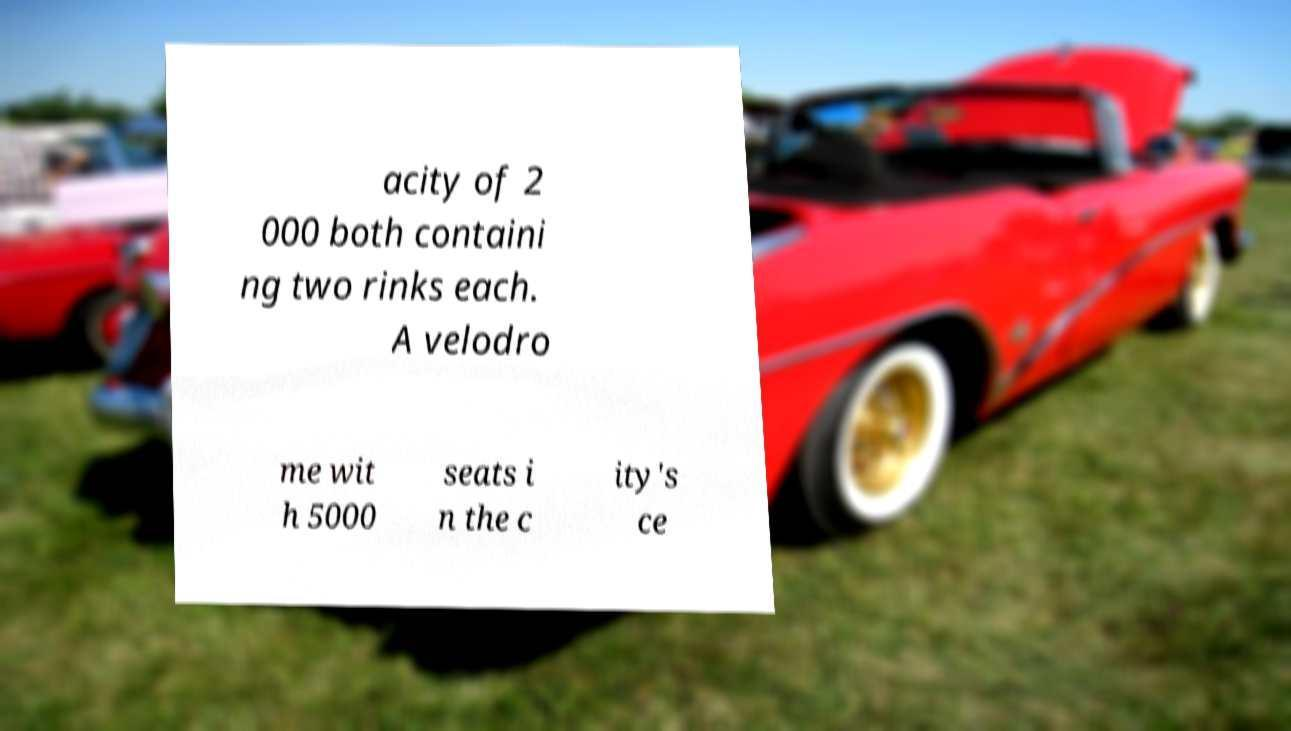What messages or text are displayed in this image? I need them in a readable, typed format. acity of 2 000 both containi ng two rinks each. A velodro me wit h 5000 seats i n the c ity's ce 